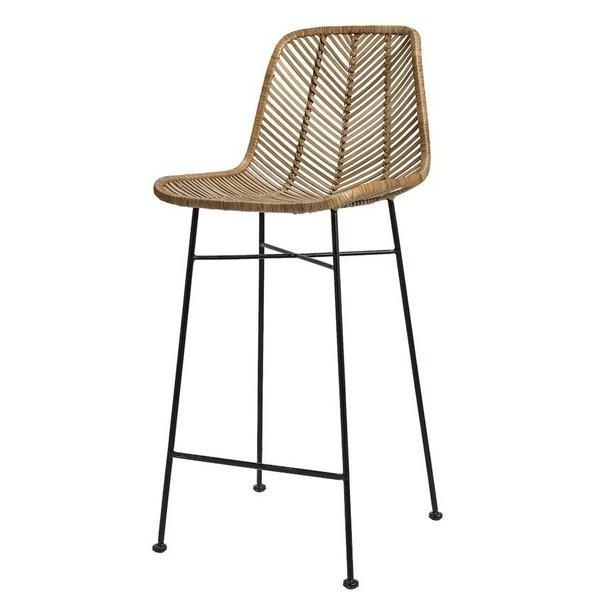How might the choice of material for the seat and backrest influence the comfort and durability of the bar stool? The woven material used for the seat and backrest of the bar stool likely provides a certain level of breathability, which can contribute to comfort during prolonged sitting by allowing air circulation. However, the firmness of the weave and the lack of cushioning might result in less comfort compared to padded seats, especially over extended periods. In terms of durability, natural fiber materials like rattan are generally quite resilient and can sustain considerable wear and tear, but they may be susceptible to damage from sharp objects or excessive moisture. The tightness of the weave contributes to the overall strength and structural integrity of the seating area, potentially enhancing its durability. Additionally, the woven design can add an aesthetic appeal, making the stool not only functional but also a stylish piece of furniture. 